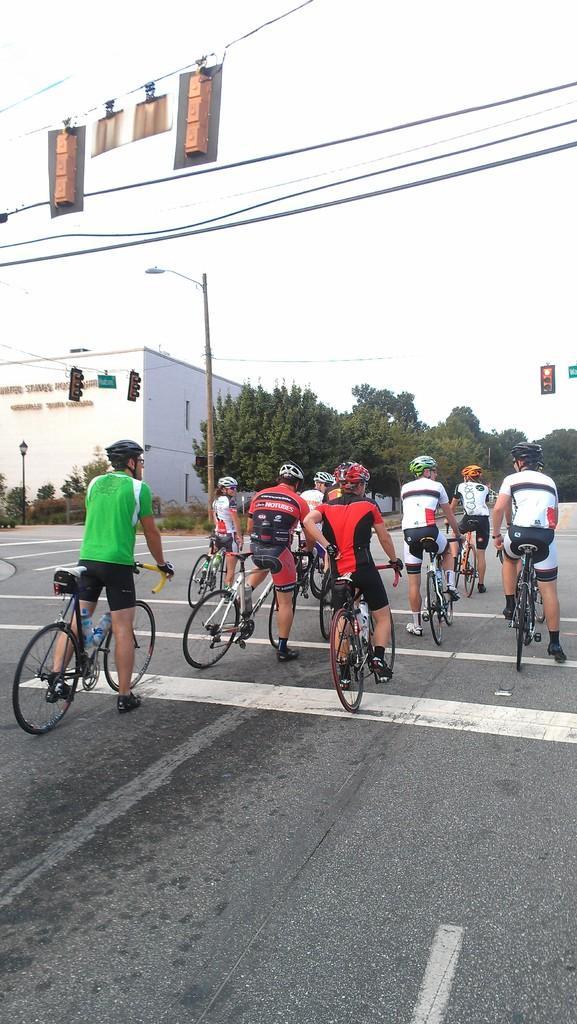In one or two sentences, can you explain what this image depicts? In the center of the image some persons are riding bicycle and wearing helmet. In the middle of the image we can see traffic lights, electric light pole, building, trees are present. At the top of the image wires, sky are there. At the top of the image road is there. 